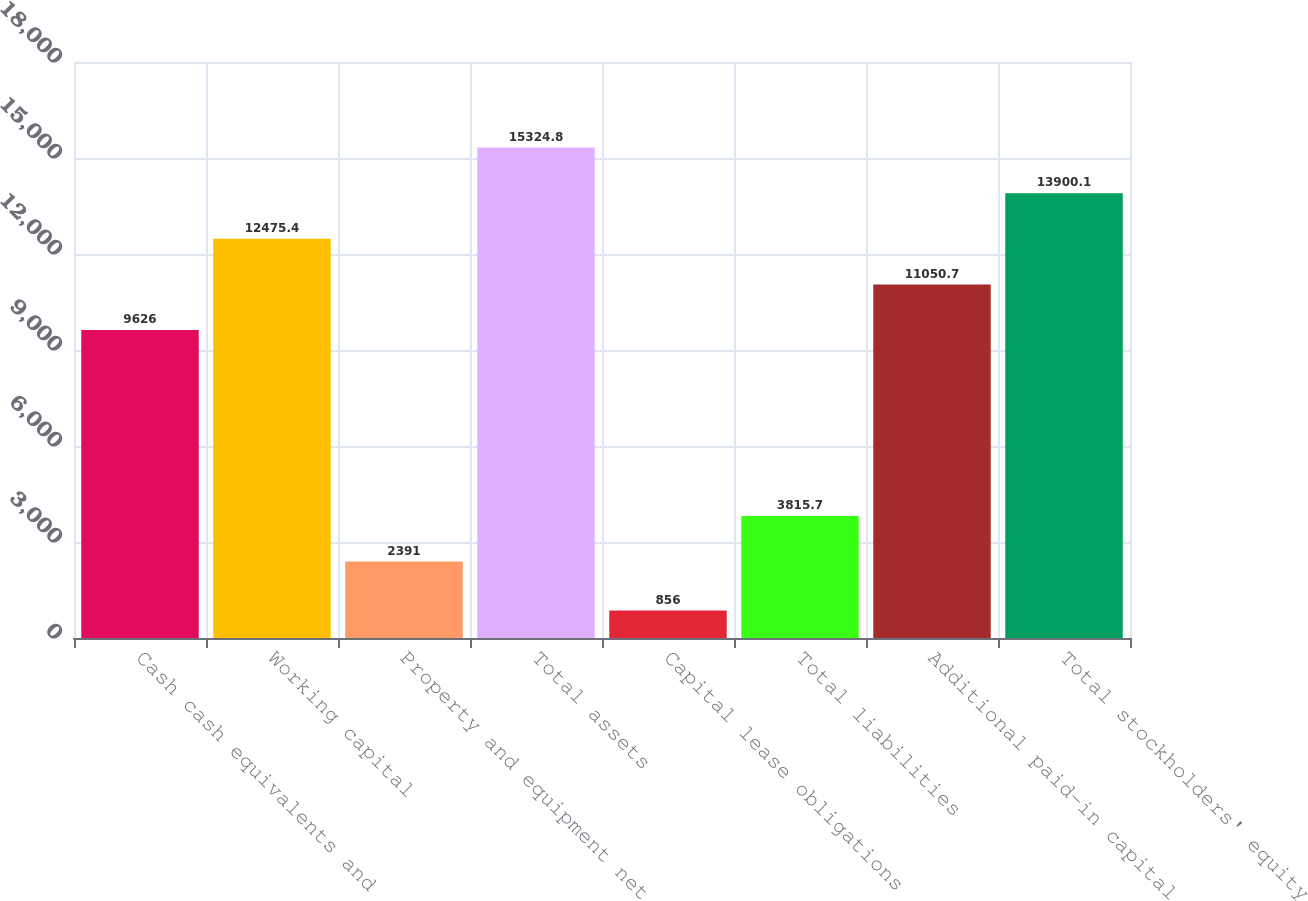Convert chart. <chart><loc_0><loc_0><loc_500><loc_500><bar_chart><fcel>Cash cash equivalents and<fcel>Working capital<fcel>Property and equipment net<fcel>Total assets<fcel>Capital lease obligations<fcel>Total liabilities<fcel>Additional paid-in capital<fcel>Total stockholders' equity<nl><fcel>9626<fcel>12475.4<fcel>2391<fcel>15324.8<fcel>856<fcel>3815.7<fcel>11050.7<fcel>13900.1<nl></chart> 